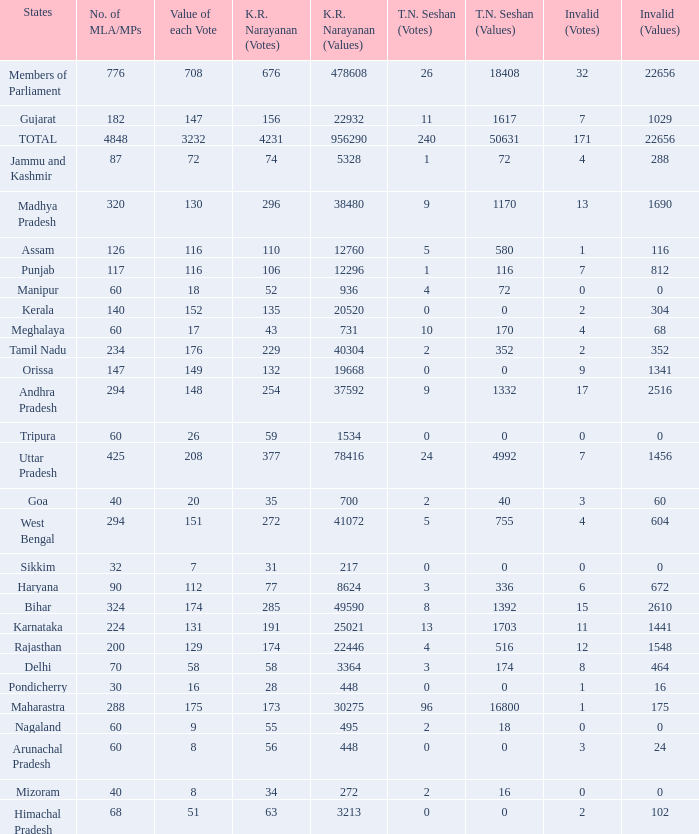Name the kr narayanan votes for values being 936 for kr 52.0. 